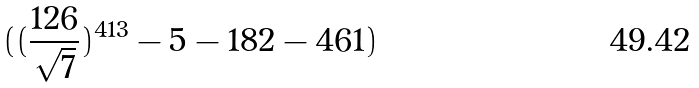<formula> <loc_0><loc_0><loc_500><loc_500>( ( \frac { 1 2 6 } { \sqrt { 7 } } ) ^ { 4 1 3 } - 5 - 1 8 2 - 4 6 1 )</formula> 